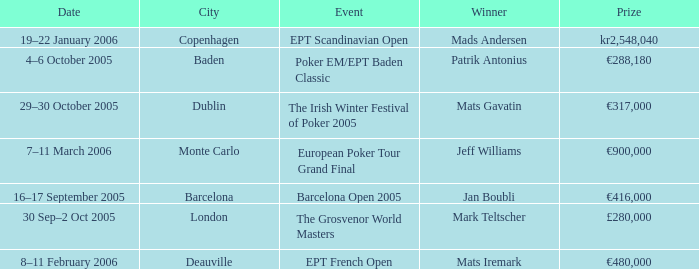When was the event in the City of Baden? 4–6 October 2005. 